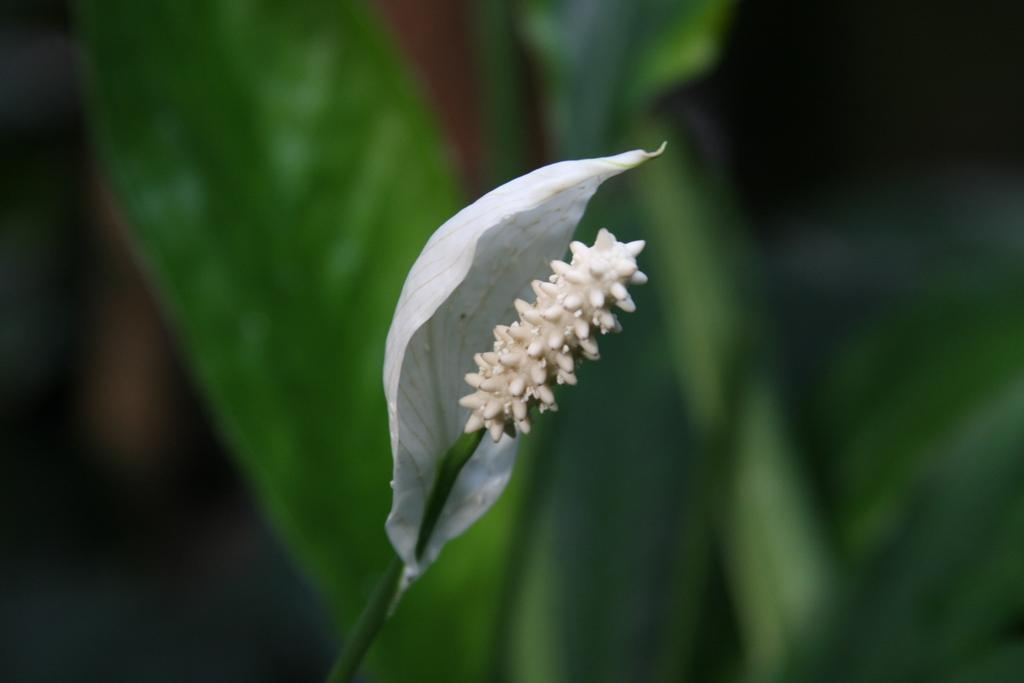What is the main subject of the image? There is a flower in the image. Can you describe the flower's structure? The flower has a stem. What is the appearance of the background in the image? The background of the image is blurred. What type of plate is being used to hold the flower in the image? There is no plate present in the image; the flower is not being held by any plate. Can you see a spade or any gardening tools in the image? There are no gardening tools, including a spade, visible in the image. 